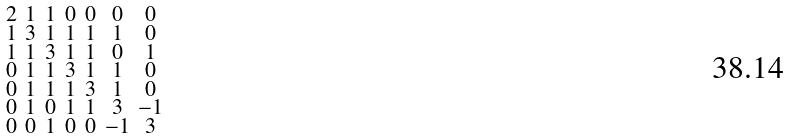<formula> <loc_0><loc_0><loc_500><loc_500>\begin{smallmatrix} 2 & 1 & 1 & 0 & 0 & 0 & 0 \\ 1 & 3 & 1 & 1 & 1 & 1 & 0 \\ 1 & 1 & 3 & 1 & 1 & 0 & 1 \\ 0 & 1 & 1 & 3 & 1 & 1 & 0 \\ 0 & 1 & 1 & 1 & 3 & 1 & 0 \\ 0 & 1 & 0 & 1 & 1 & 3 & - 1 \\ 0 & 0 & 1 & 0 & 0 & - 1 & 3 \end{smallmatrix}</formula> 